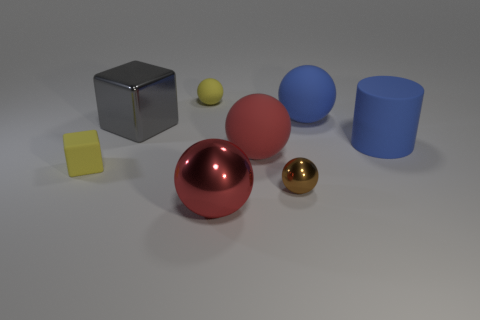The rubber cylinder that is in front of the tiny yellow thing behind the tiny matte object that is in front of the big red rubber object is what color?
Offer a terse response. Blue. There is a small thing that is made of the same material as the big gray thing; what is its shape?
Make the answer very short. Sphere. Is the number of matte spheres less than the number of objects?
Offer a very short reply. Yes. Is the big cylinder made of the same material as the small yellow cube?
Keep it short and to the point. Yes. How many other things are there of the same color as the small shiny sphere?
Your answer should be very brief. 0. Is the number of yellow matte things greater than the number of tiny blue balls?
Offer a very short reply. Yes. There is a yellow matte sphere; does it have the same size as the rubber block on the left side of the small brown sphere?
Give a very brief answer. Yes. There is a large shiny thing behind the small shiny thing; what color is it?
Keep it short and to the point. Gray. What number of green objects are small things or large shiny blocks?
Make the answer very short. 0. The small metallic thing is what color?
Your answer should be compact. Brown. 